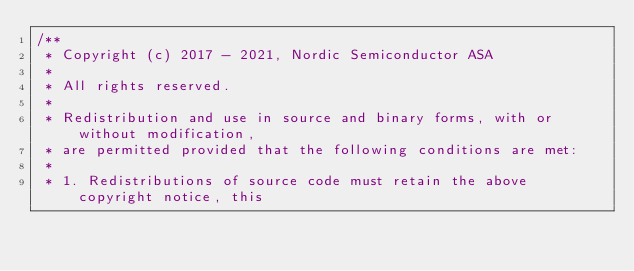Convert code to text. <code><loc_0><loc_0><loc_500><loc_500><_C_>/**
 * Copyright (c) 2017 - 2021, Nordic Semiconductor ASA
 *
 * All rights reserved.
 *
 * Redistribution and use in source and binary forms, with or without modification,
 * are permitted provided that the following conditions are met:
 *
 * 1. Redistributions of source code must retain the above copyright notice, this</code> 